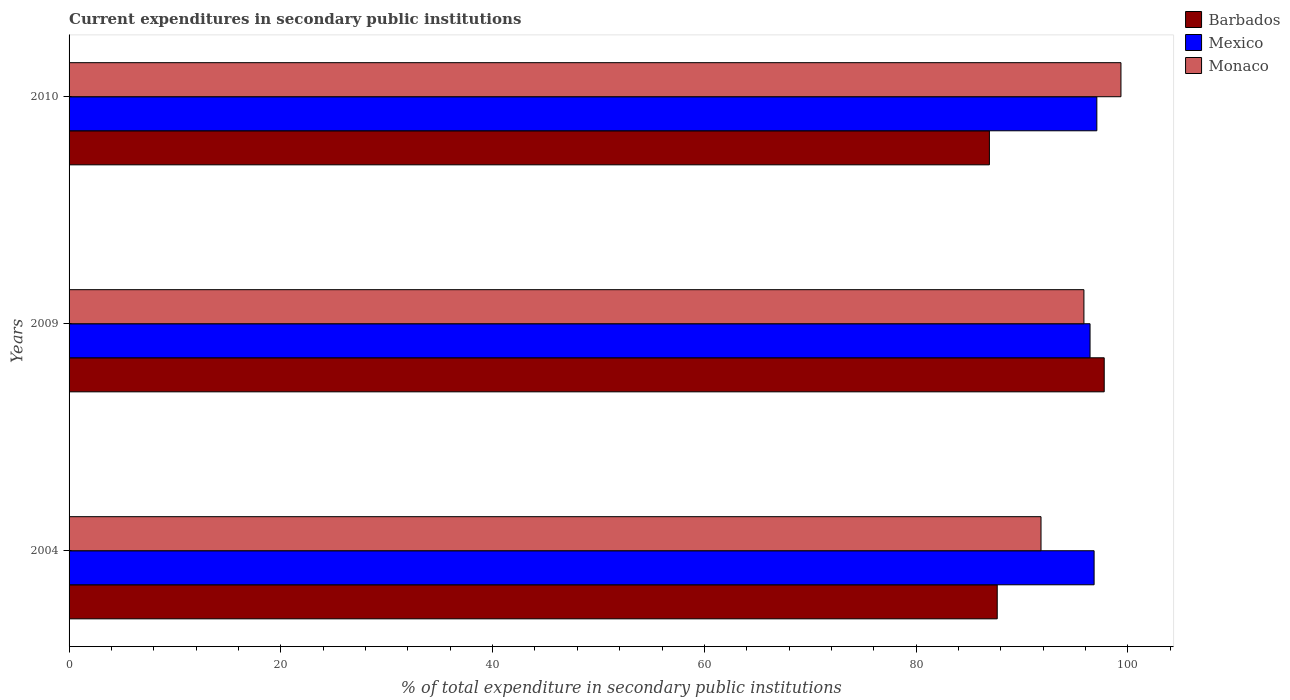How many different coloured bars are there?
Your response must be concise. 3. Are the number of bars per tick equal to the number of legend labels?
Give a very brief answer. Yes. Are the number of bars on each tick of the Y-axis equal?
Your answer should be compact. Yes. How many bars are there on the 2nd tick from the top?
Your answer should be very brief. 3. What is the current expenditures in secondary public institutions in Monaco in 2009?
Ensure brevity in your answer.  95.84. Across all years, what is the maximum current expenditures in secondary public institutions in Monaco?
Offer a very short reply. 99.34. Across all years, what is the minimum current expenditures in secondary public institutions in Monaco?
Give a very brief answer. 91.79. In which year was the current expenditures in secondary public institutions in Barbados maximum?
Your response must be concise. 2009. What is the total current expenditures in secondary public institutions in Monaco in the graph?
Your answer should be very brief. 286.97. What is the difference between the current expenditures in secondary public institutions in Barbados in 2009 and that in 2010?
Ensure brevity in your answer.  10.84. What is the difference between the current expenditures in secondary public institutions in Monaco in 2004 and the current expenditures in secondary public institutions in Barbados in 2009?
Offer a terse response. -5.97. What is the average current expenditures in secondary public institutions in Barbados per year?
Ensure brevity in your answer.  90.78. In the year 2004, what is the difference between the current expenditures in secondary public institutions in Monaco and current expenditures in secondary public institutions in Barbados?
Give a very brief answer. 4.13. What is the ratio of the current expenditures in secondary public institutions in Mexico in 2004 to that in 2009?
Offer a very short reply. 1. What is the difference between the highest and the second highest current expenditures in secondary public institutions in Barbados?
Your answer should be compact. 10.1. What is the difference between the highest and the lowest current expenditures in secondary public institutions in Mexico?
Your answer should be compact. 0.64. Is the sum of the current expenditures in secondary public institutions in Barbados in 2004 and 2009 greater than the maximum current expenditures in secondary public institutions in Mexico across all years?
Keep it short and to the point. Yes. What does the 1st bar from the top in 2009 represents?
Your answer should be very brief. Monaco. What does the 3rd bar from the bottom in 2009 represents?
Offer a very short reply. Monaco. Are all the bars in the graph horizontal?
Keep it short and to the point. Yes. How many years are there in the graph?
Provide a short and direct response. 3. Are the values on the major ticks of X-axis written in scientific E-notation?
Provide a short and direct response. No. Where does the legend appear in the graph?
Offer a terse response. Top right. How many legend labels are there?
Offer a very short reply. 3. How are the legend labels stacked?
Keep it short and to the point. Vertical. What is the title of the graph?
Your answer should be compact. Current expenditures in secondary public institutions. What is the label or title of the X-axis?
Make the answer very short. % of total expenditure in secondary public institutions. What is the % of total expenditure in secondary public institutions of Barbados in 2004?
Your answer should be compact. 87.65. What is the % of total expenditure in secondary public institutions in Mexico in 2004?
Offer a terse response. 96.8. What is the % of total expenditure in secondary public institutions in Monaco in 2004?
Ensure brevity in your answer.  91.79. What is the % of total expenditure in secondary public institutions in Barbados in 2009?
Offer a terse response. 97.76. What is the % of total expenditure in secondary public institutions of Mexico in 2009?
Ensure brevity in your answer.  96.42. What is the % of total expenditure in secondary public institutions in Monaco in 2009?
Your answer should be very brief. 95.84. What is the % of total expenditure in secondary public institutions in Barbados in 2010?
Provide a succinct answer. 86.92. What is the % of total expenditure in secondary public institutions in Mexico in 2010?
Give a very brief answer. 97.06. What is the % of total expenditure in secondary public institutions in Monaco in 2010?
Your answer should be very brief. 99.34. Across all years, what is the maximum % of total expenditure in secondary public institutions of Barbados?
Give a very brief answer. 97.76. Across all years, what is the maximum % of total expenditure in secondary public institutions in Mexico?
Provide a short and direct response. 97.06. Across all years, what is the maximum % of total expenditure in secondary public institutions of Monaco?
Give a very brief answer. 99.34. Across all years, what is the minimum % of total expenditure in secondary public institutions of Barbados?
Your response must be concise. 86.92. Across all years, what is the minimum % of total expenditure in secondary public institutions of Mexico?
Make the answer very short. 96.42. Across all years, what is the minimum % of total expenditure in secondary public institutions in Monaco?
Give a very brief answer. 91.79. What is the total % of total expenditure in secondary public institutions in Barbados in the graph?
Your answer should be compact. 272.33. What is the total % of total expenditure in secondary public institutions in Mexico in the graph?
Your response must be concise. 290.28. What is the total % of total expenditure in secondary public institutions of Monaco in the graph?
Offer a very short reply. 286.97. What is the difference between the % of total expenditure in secondary public institutions of Barbados in 2004 and that in 2009?
Offer a terse response. -10.1. What is the difference between the % of total expenditure in secondary public institutions in Mexico in 2004 and that in 2009?
Your response must be concise. 0.38. What is the difference between the % of total expenditure in secondary public institutions in Monaco in 2004 and that in 2009?
Offer a very short reply. -4.05. What is the difference between the % of total expenditure in secondary public institutions of Barbados in 2004 and that in 2010?
Your response must be concise. 0.74. What is the difference between the % of total expenditure in secondary public institutions in Mexico in 2004 and that in 2010?
Offer a very short reply. -0.26. What is the difference between the % of total expenditure in secondary public institutions of Monaco in 2004 and that in 2010?
Ensure brevity in your answer.  -7.55. What is the difference between the % of total expenditure in secondary public institutions in Barbados in 2009 and that in 2010?
Make the answer very short. 10.84. What is the difference between the % of total expenditure in secondary public institutions in Mexico in 2009 and that in 2010?
Offer a terse response. -0.64. What is the difference between the % of total expenditure in secondary public institutions in Monaco in 2009 and that in 2010?
Your answer should be very brief. -3.5. What is the difference between the % of total expenditure in secondary public institutions of Barbados in 2004 and the % of total expenditure in secondary public institutions of Mexico in 2009?
Your answer should be compact. -8.76. What is the difference between the % of total expenditure in secondary public institutions in Barbados in 2004 and the % of total expenditure in secondary public institutions in Monaco in 2009?
Your response must be concise. -8.19. What is the difference between the % of total expenditure in secondary public institutions in Mexico in 2004 and the % of total expenditure in secondary public institutions in Monaco in 2009?
Offer a terse response. 0.96. What is the difference between the % of total expenditure in secondary public institutions of Barbados in 2004 and the % of total expenditure in secondary public institutions of Mexico in 2010?
Offer a terse response. -9.41. What is the difference between the % of total expenditure in secondary public institutions of Barbados in 2004 and the % of total expenditure in secondary public institutions of Monaco in 2010?
Offer a very short reply. -11.68. What is the difference between the % of total expenditure in secondary public institutions of Mexico in 2004 and the % of total expenditure in secondary public institutions of Monaco in 2010?
Give a very brief answer. -2.54. What is the difference between the % of total expenditure in secondary public institutions in Barbados in 2009 and the % of total expenditure in secondary public institutions in Mexico in 2010?
Provide a succinct answer. 0.7. What is the difference between the % of total expenditure in secondary public institutions of Barbados in 2009 and the % of total expenditure in secondary public institutions of Monaco in 2010?
Offer a terse response. -1.58. What is the difference between the % of total expenditure in secondary public institutions in Mexico in 2009 and the % of total expenditure in secondary public institutions in Monaco in 2010?
Your answer should be very brief. -2.92. What is the average % of total expenditure in secondary public institutions of Barbados per year?
Offer a very short reply. 90.78. What is the average % of total expenditure in secondary public institutions of Mexico per year?
Ensure brevity in your answer.  96.76. What is the average % of total expenditure in secondary public institutions in Monaco per year?
Keep it short and to the point. 95.66. In the year 2004, what is the difference between the % of total expenditure in secondary public institutions of Barbados and % of total expenditure in secondary public institutions of Mexico?
Your answer should be very brief. -9.15. In the year 2004, what is the difference between the % of total expenditure in secondary public institutions in Barbados and % of total expenditure in secondary public institutions in Monaco?
Provide a succinct answer. -4.13. In the year 2004, what is the difference between the % of total expenditure in secondary public institutions in Mexico and % of total expenditure in secondary public institutions in Monaco?
Provide a short and direct response. 5.01. In the year 2009, what is the difference between the % of total expenditure in secondary public institutions of Barbados and % of total expenditure in secondary public institutions of Mexico?
Provide a short and direct response. 1.34. In the year 2009, what is the difference between the % of total expenditure in secondary public institutions in Barbados and % of total expenditure in secondary public institutions in Monaco?
Ensure brevity in your answer.  1.92. In the year 2009, what is the difference between the % of total expenditure in secondary public institutions in Mexico and % of total expenditure in secondary public institutions in Monaco?
Ensure brevity in your answer.  0.58. In the year 2010, what is the difference between the % of total expenditure in secondary public institutions in Barbados and % of total expenditure in secondary public institutions in Mexico?
Offer a very short reply. -10.15. In the year 2010, what is the difference between the % of total expenditure in secondary public institutions in Barbados and % of total expenditure in secondary public institutions in Monaco?
Your answer should be compact. -12.42. In the year 2010, what is the difference between the % of total expenditure in secondary public institutions in Mexico and % of total expenditure in secondary public institutions in Monaco?
Ensure brevity in your answer.  -2.28. What is the ratio of the % of total expenditure in secondary public institutions in Barbados in 2004 to that in 2009?
Your answer should be very brief. 0.9. What is the ratio of the % of total expenditure in secondary public institutions in Monaco in 2004 to that in 2009?
Offer a very short reply. 0.96. What is the ratio of the % of total expenditure in secondary public institutions of Barbados in 2004 to that in 2010?
Your answer should be very brief. 1.01. What is the ratio of the % of total expenditure in secondary public institutions of Mexico in 2004 to that in 2010?
Ensure brevity in your answer.  1. What is the ratio of the % of total expenditure in secondary public institutions in Monaco in 2004 to that in 2010?
Make the answer very short. 0.92. What is the ratio of the % of total expenditure in secondary public institutions of Barbados in 2009 to that in 2010?
Your answer should be compact. 1.12. What is the ratio of the % of total expenditure in secondary public institutions in Mexico in 2009 to that in 2010?
Keep it short and to the point. 0.99. What is the ratio of the % of total expenditure in secondary public institutions in Monaco in 2009 to that in 2010?
Give a very brief answer. 0.96. What is the difference between the highest and the second highest % of total expenditure in secondary public institutions in Barbados?
Provide a short and direct response. 10.1. What is the difference between the highest and the second highest % of total expenditure in secondary public institutions of Mexico?
Give a very brief answer. 0.26. What is the difference between the highest and the second highest % of total expenditure in secondary public institutions of Monaco?
Make the answer very short. 3.5. What is the difference between the highest and the lowest % of total expenditure in secondary public institutions in Barbados?
Your answer should be very brief. 10.84. What is the difference between the highest and the lowest % of total expenditure in secondary public institutions of Mexico?
Your answer should be compact. 0.64. What is the difference between the highest and the lowest % of total expenditure in secondary public institutions of Monaco?
Your answer should be compact. 7.55. 